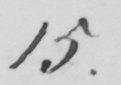Please transcribe the handwritten text in this image. 15. 